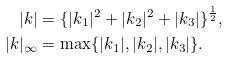<formula> <loc_0><loc_0><loc_500><loc_500>| k | & = \{ | k _ { 1 } | ^ { 2 } + | k _ { 2 } | ^ { 2 } + | k _ { 3 } | \} ^ { \frac { 1 } { 2 } } , \\ | k | _ { \infty } & = \max \{ | k _ { 1 } | , | k _ { 2 } | , | k _ { 3 } | \} .</formula> 